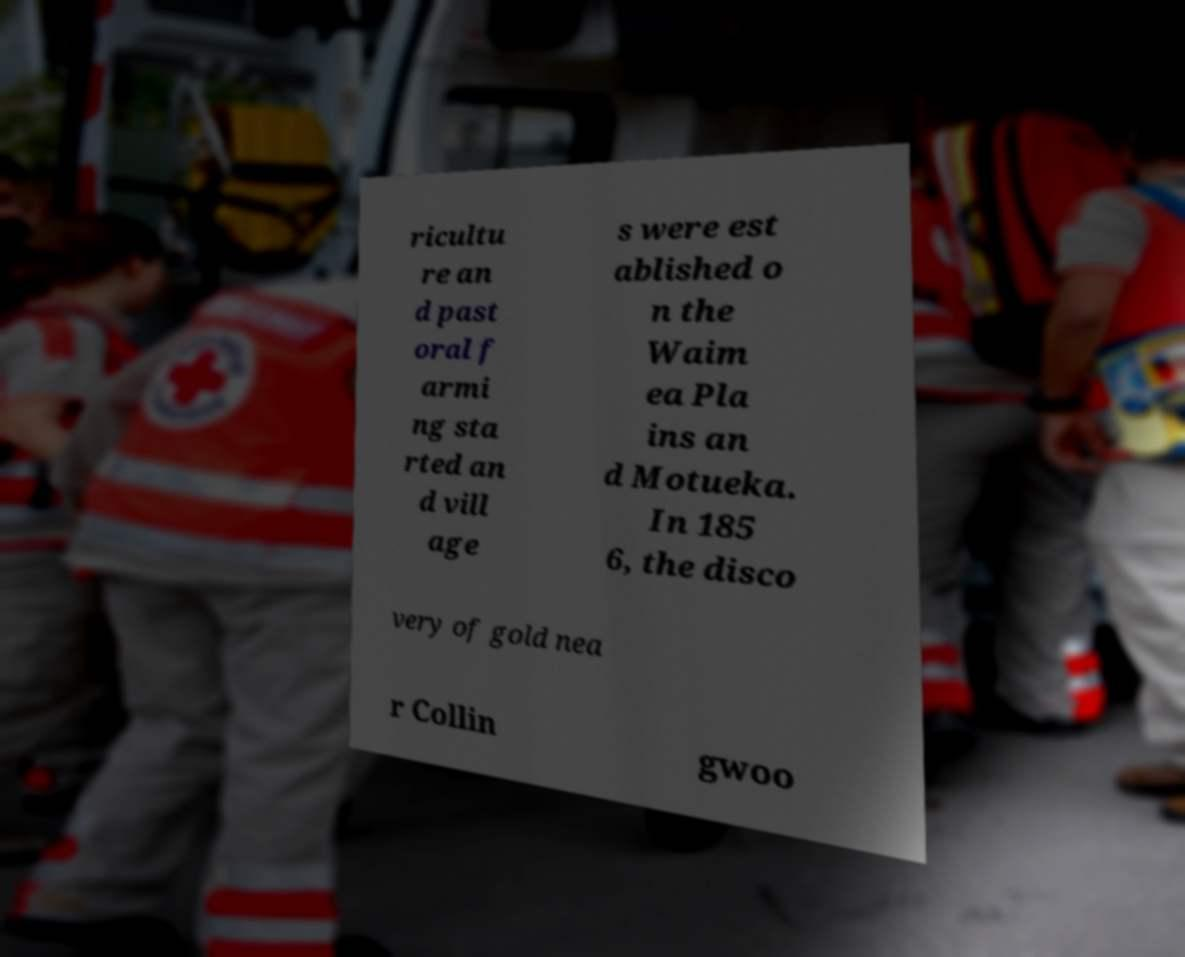What messages or text are displayed in this image? I need them in a readable, typed format. ricultu re an d past oral f armi ng sta rted an d vill age s were est ablished o n the Waim ea Pla ins an d Motueka. In 185 6, the disco very of gold nea r Collin gwoo 